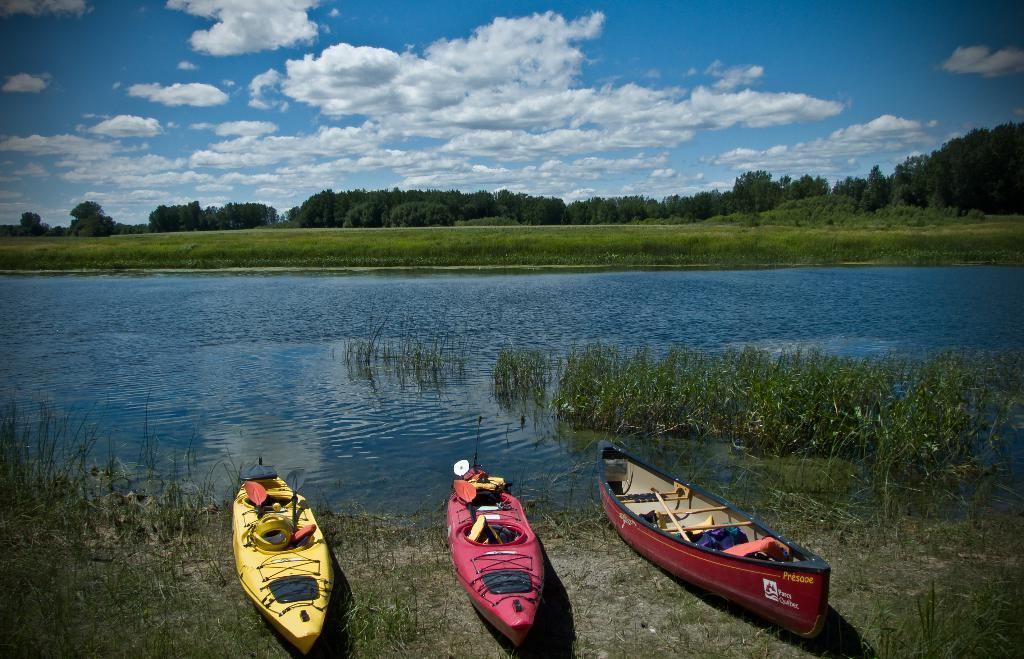What objects are placed on the river bed in the image? There are boats placed on the river bed in the image. What type of vegetation can be seen in the image? There is grass visible in the image. What body of water is present in the image? There is a river in the image. What type of plants are visible in the image? There are trees in the image. What part of the natural environment is visible in the image? The sky is visible in the image. What can be seen in the sky in the image? Clouds are present in the sky. Can you see a guide leading a group of tourists through the cobweb in the image? There is no guide or tourists present in the image, nor is there a cobweb. 